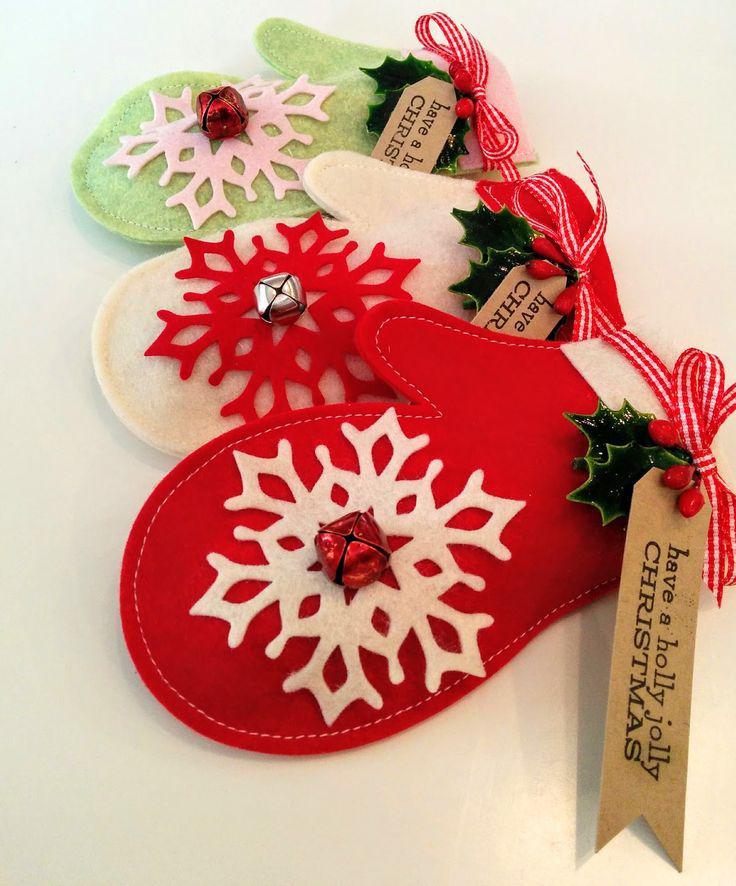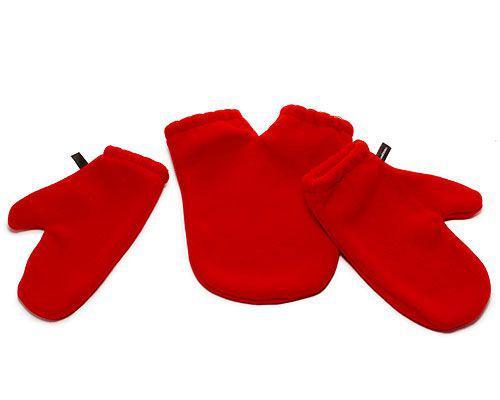The first image is the image on the left, the second image is the image on the right. Given the left and right images, does the statement "All of the mittens in the image on the right are red." hold true? Answer yes or no. Yes. 